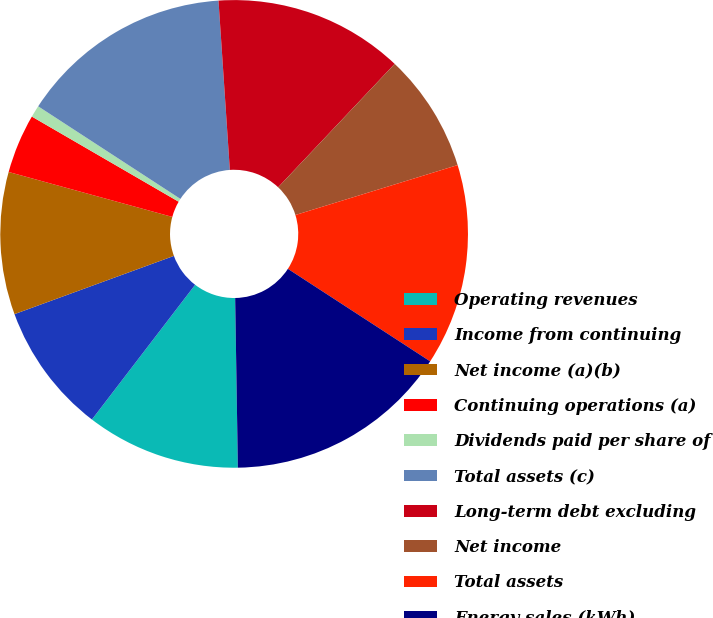Convert chart. <chart><loc_0><loc_0><loc_500><loc_500><pie_chart><fcel>Operating revenues<fcel>Income from continuing<fcel>Net income (a)(b)<fcel>Continuing operations (a)<fcel>Dividends paid per share of<fcel>Total assets (c)<fcel>Long-term debt excluding<fcel>Net income<fcel>Total assets<fcel>Energy sales (kWh)<nl><fcel>10.66%<fcel>9.02%<fcel>9.84%<fcel>4.1%<fcel>0.82%<fcel>14.75%<fcel>13.11%<fcel>8.2%<fcel>13.93%<fcel>15.57%<nl></chart> 